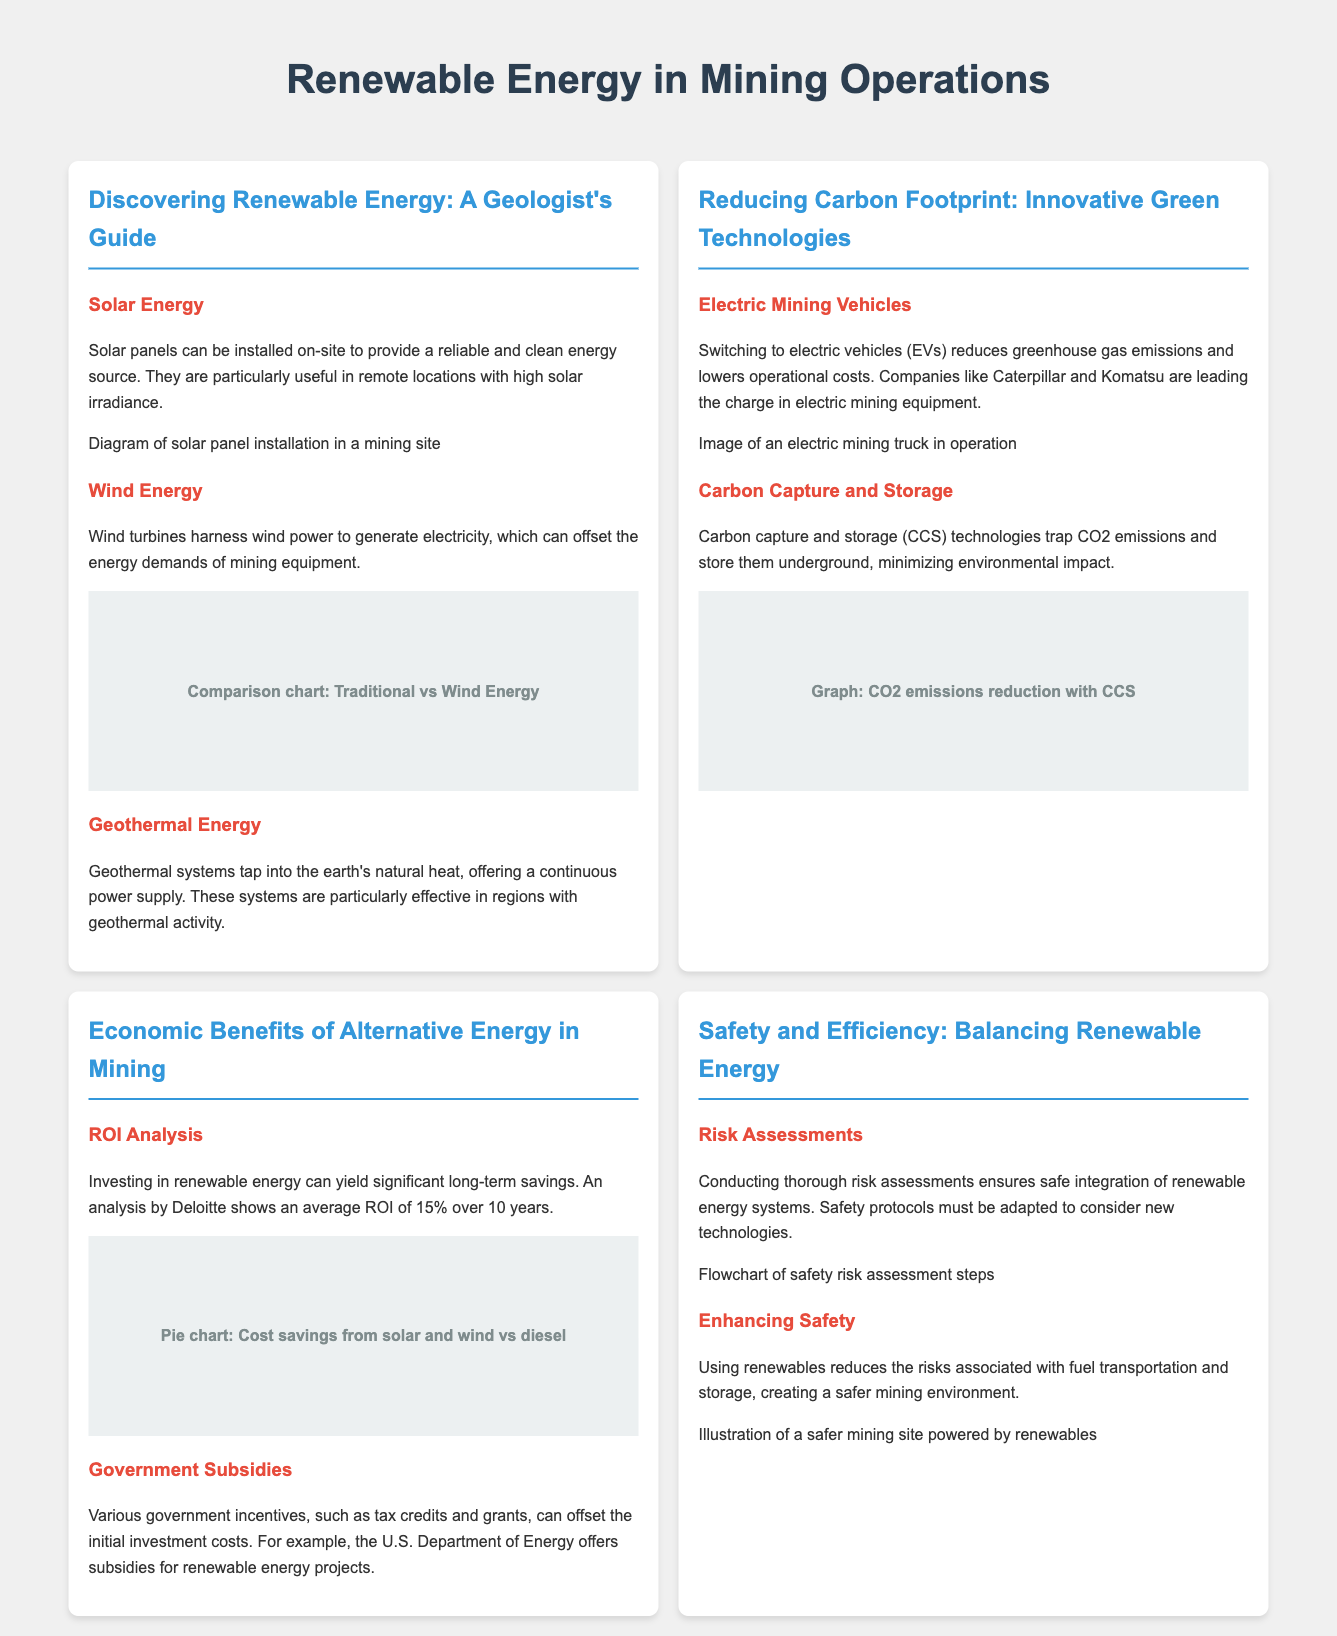What are the three renewable energy sources mentioned? The document lists solar, wind, and geothermal energy as the three renewable energy sources tailored for mining operations.
Answer: Solar, wind, geothermal What is the average ROI for renewable energy investments over 10 years? According to the ROI analysis mentioned in the document, investing in renewable energy can yield an average ROI of 15% over 10 years.
Answer: 15% Which company is leading in electric mining equipment? The document mentions Caterpillar and Komatsu as companies that are leading the charge in electric mining equipment.
Answer: Caterpillar, Komatsu What technology is used to minimize environmental impact by storing CO2? The document references carbon capture and storage (CCS) technologies as a means to trap and store CO2 emissions, minimizing environmental impact.
Answer: Carbon capture and storage What is one benefit of using renewable energy in terms of safety? The flyer notes that using renewables reduces the risks associated with fuel transportation and storage, thus creating a safer mining environment.
Answer: Reduces fuel risks 